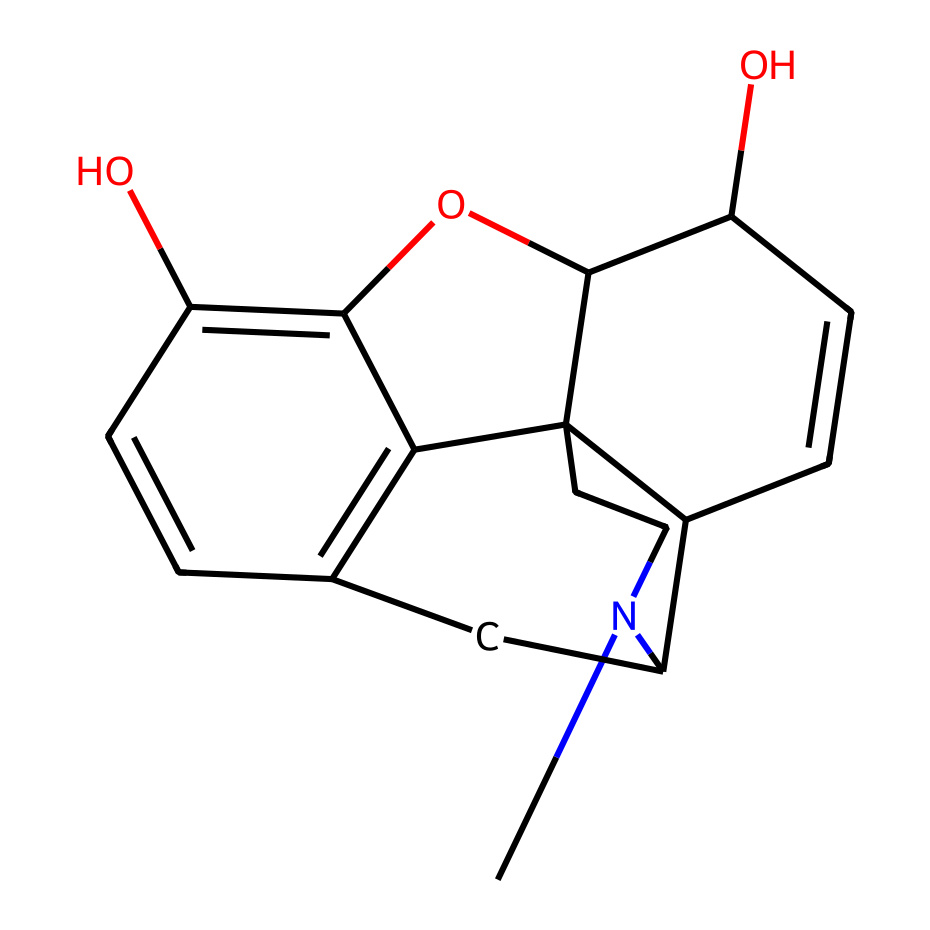What is the molecular formula of morphine? To determine the molecular formula, we need to count the number of carbon, hydrogen, nitrogen, and oxygen atoms in the structure. Analyzing the SMILES shows that there are 17 carbon atoms, 19 hydrogen atoms, 1 nitrogen atom, and 3 oxygen atoms, leading to the formula C17H19NO3.
Answer: C17H19NO3 How many rings are present in the morphine structure? By examining the connectivity of the carbon atoms in the structure, we can identify that there are five distinct rings in the morphine molecule, which is characteristic of its alkaloid structure.
Answer: 5 What type of receptors does morphine primarily interact with in the brain? Morphine primarily interacts with opioid receptors in the brain, specifically the mu-opioid receptors, which are known for their role in pain relief and euphoria.
Answer: mu-opioid receptors What is the significance of the nitrogen atom in morphine's structure? The nitrogen atom is a key component in morphine that contributes to its pharmacological activity by forming hydrogen bonds with opioid receptors, influencing its binding affinity and potency as an analgesic.
Answer: pharmacological activity Which functional groups are present in the morphine structure? The morphine structure contains hydroxyl (-OH) functional groups and a tertiary amine from the nitrogen atom, which are critical for its biological activity and solubility properties.
Answer: hydroxyl and amine What role does the hydroxyl group play in morphine’s effectiveness? The hydroxyl groups in morphine participate in hydrogen bonding with the opioid receptors, enhancing its binding and overall effectiveness in modulating pain perception.
Answer: binding enhancement 